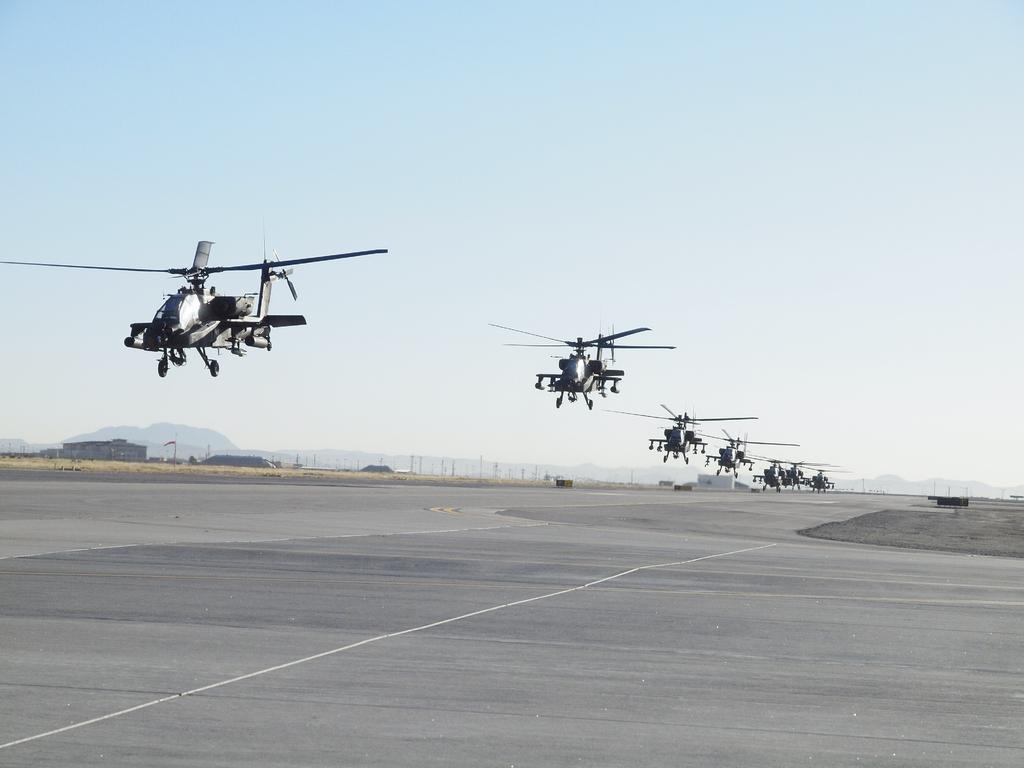Describe this image in one or two sentences. In this picture we can see a ground, here we can see helicopters, sheds, electric poles and in the background we can see mountains, sky. 